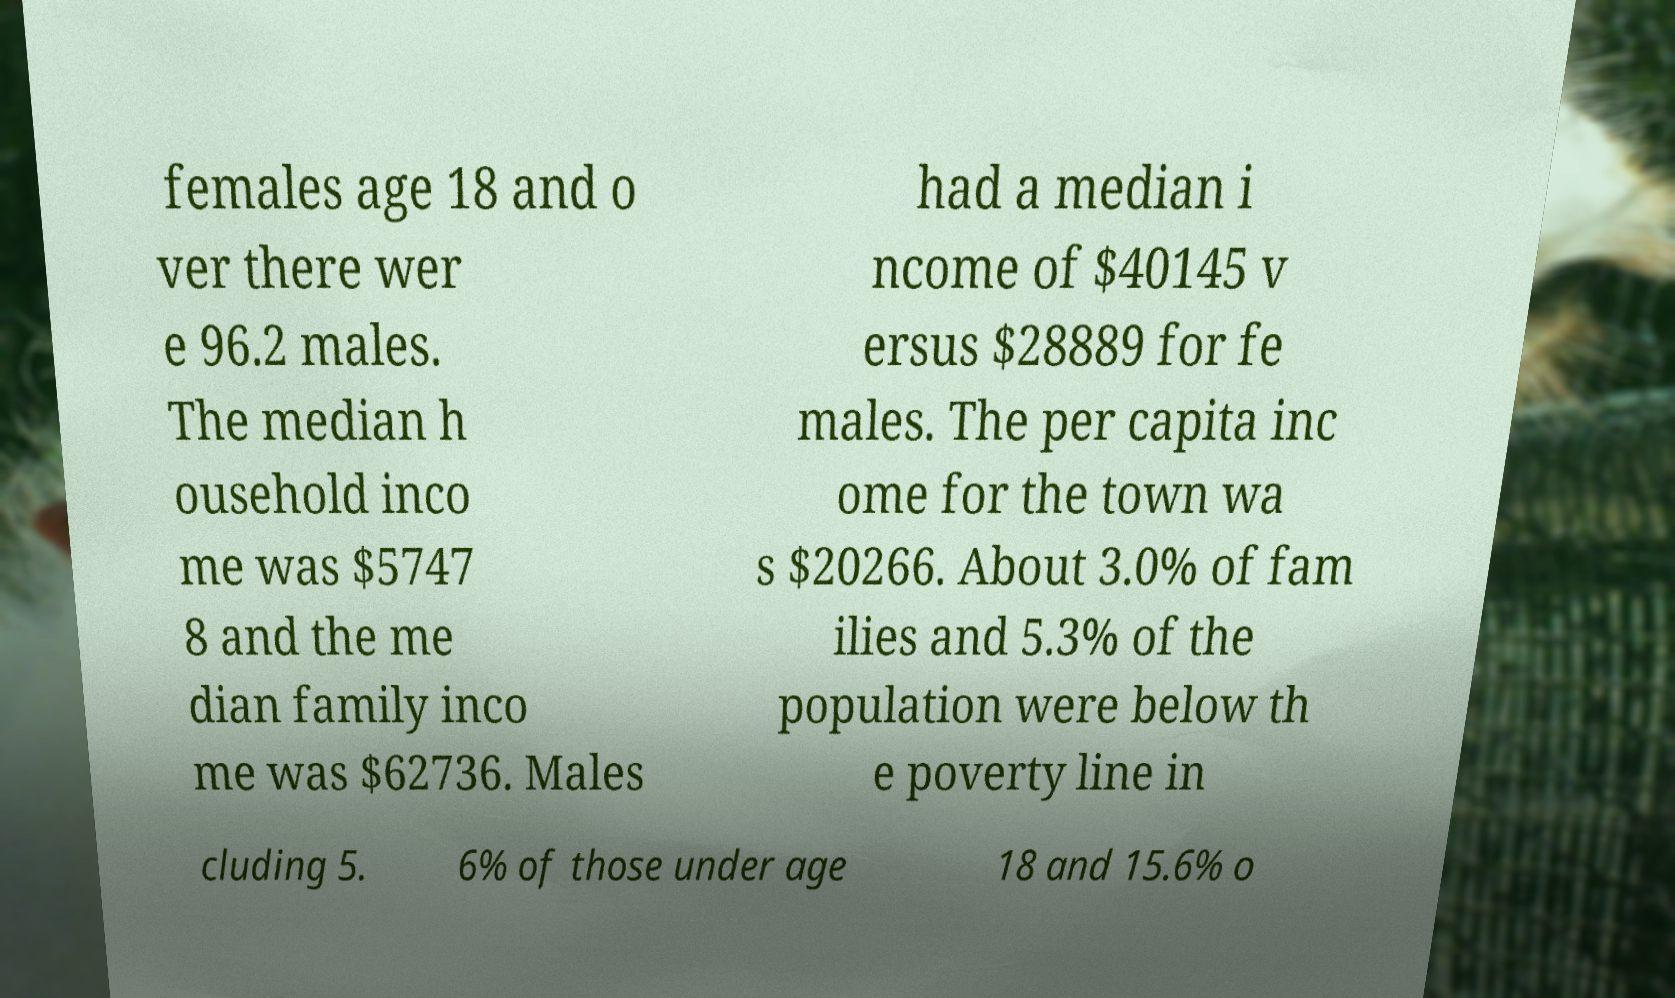For documentation purposes, I need the text within this image transcribed. Could you provide that? females age 18 and o ver there wer e 96.2 males. The median h ousehold inco me was $5747 8 and the me dian family inco me was $62736. Males had a median i ncome of $40145 v ersus $28889 for fe males. The per capita inc ome for the town wa s $20266. About 3.0% of fam ilies and 5.3% of the population were below th e poverty line in cluding 5. 6% of those under age 18 and 15.6% o 